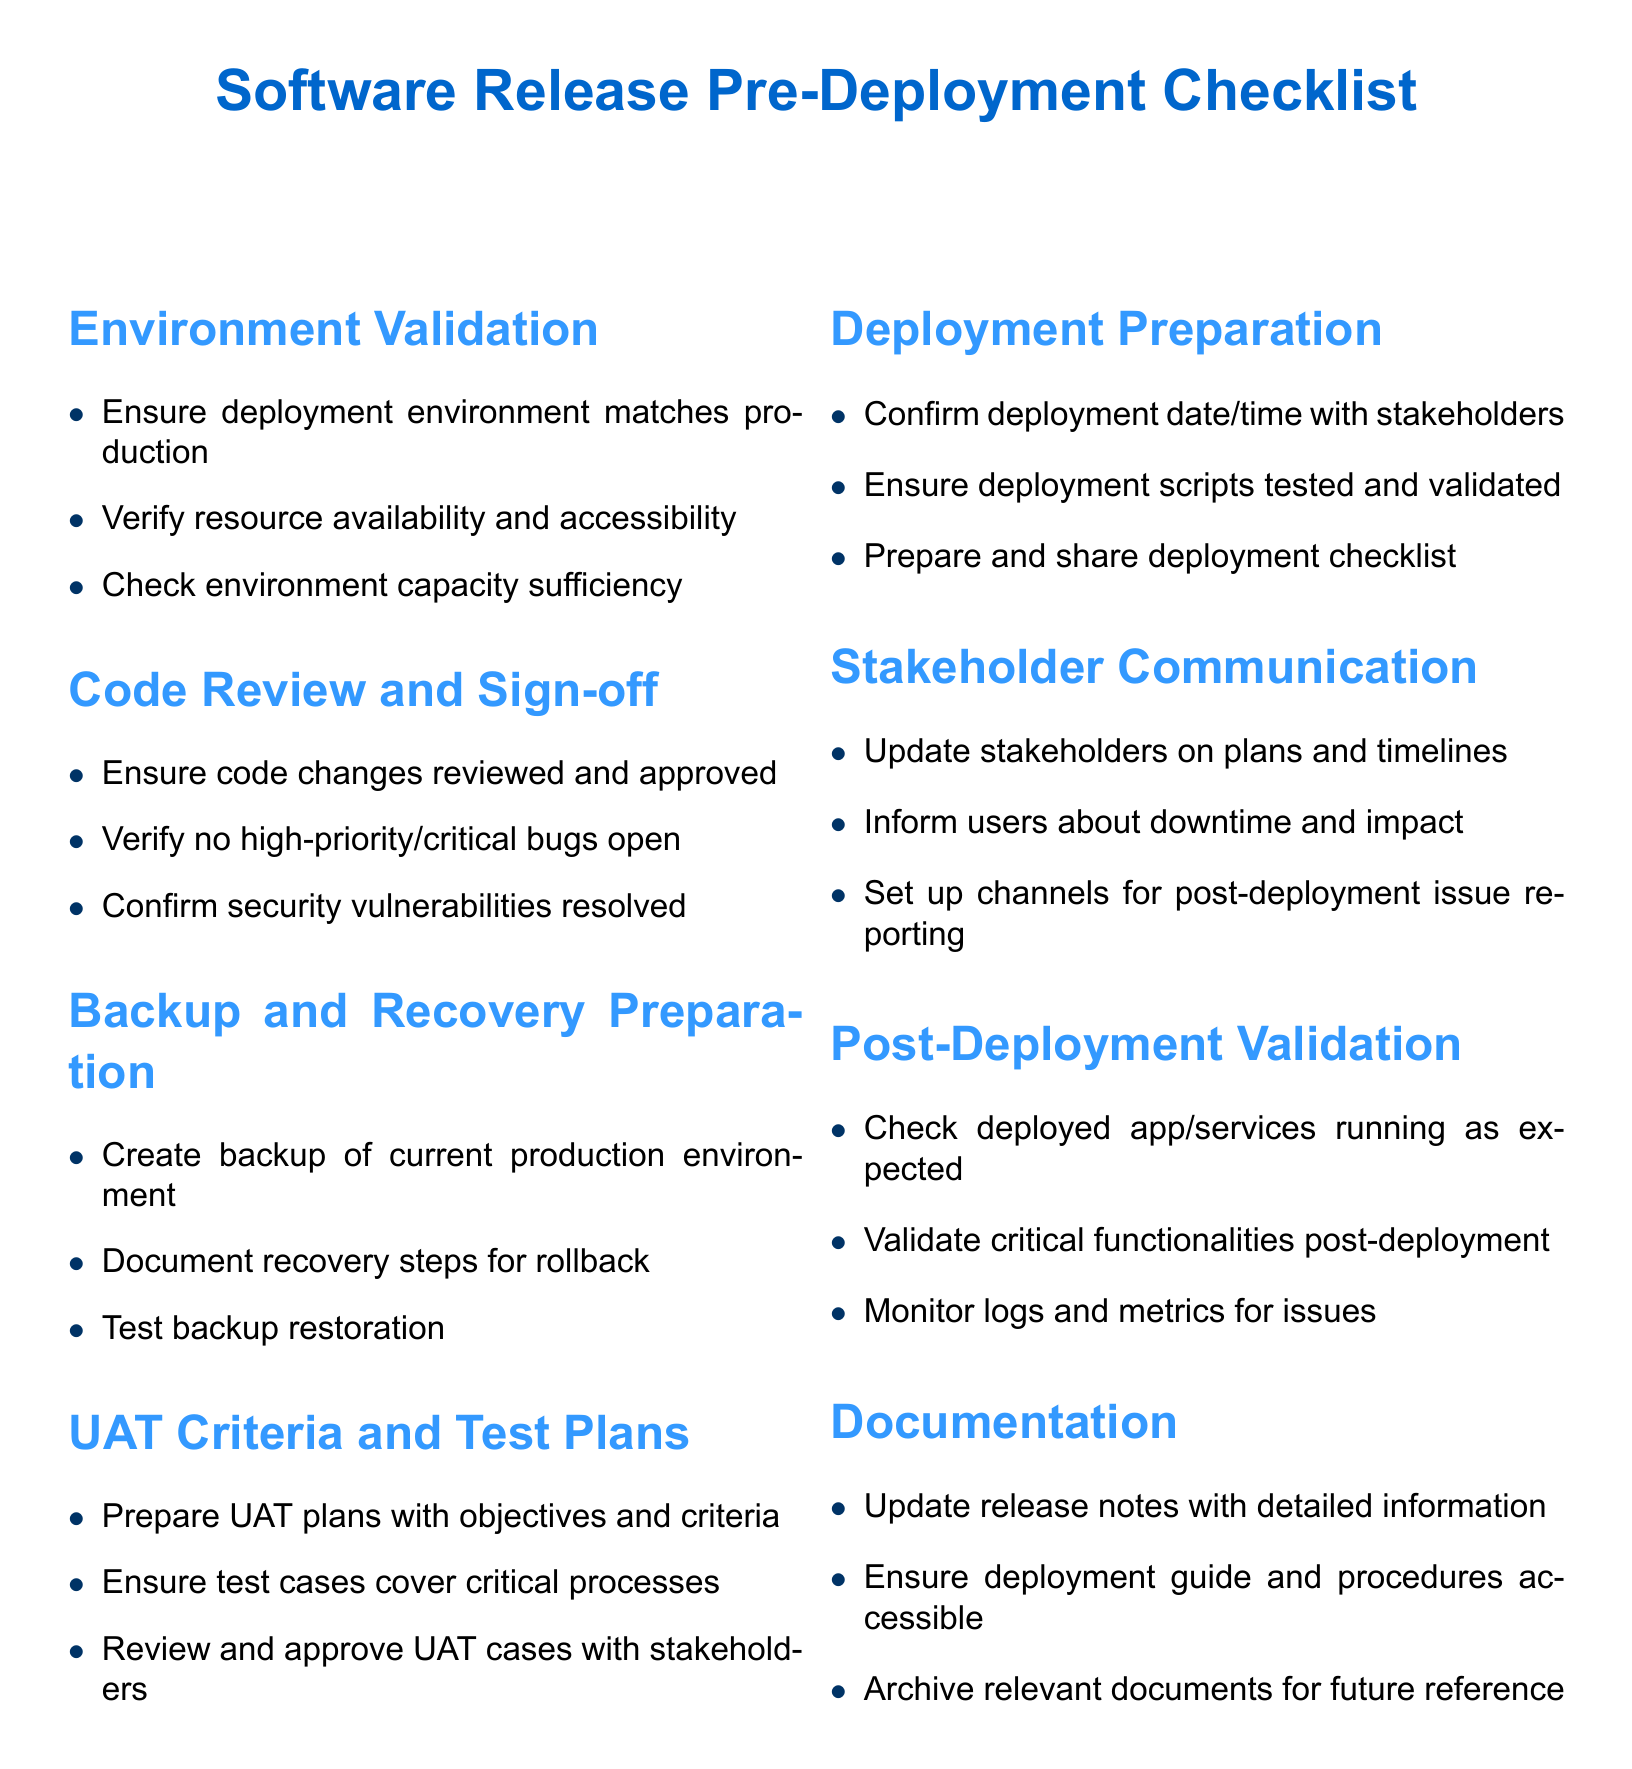What is the first section of the checklist? The checklist begins with the "Environment Validation" section, which covers the validation of the deployment environment.
Answer: Environment Validation How many items are listed under "Code Review and Sign-off"? The "Code Review and Sign-off" section contains three items for validation and sign-off requirements before deployment.
Answer: 3 What does the "Backup and Recovery Preparation" include? This section details creating a backup, documenting recovery steps, and testing backup restoration to ensure recovery readiness.
Answer: Backup creation, recovery steps, restoration testing Who needs to approve the UAT cases? UAT cases must be reviewed and approved by stakeholders to ensure proper validation before going live.
Answer: Stakeholders What is one of the objectives of the "Stakeholder Communication"? Stakeholder communication aims to update stakeholders on plans and timelines, ensuring they are informed about the deployment's impact.
Answer: Update stakeholders How many sections are there in total in the checklist? The checklist consists of eight sections covering various aspects of software deployment preparation.
Answer: 8 What is a critical requirement before "Deployment Preparation"? A critical requirement before deployment preparation is confirming the deployment date and time with stakeholders to ensure alignment.
Answer: Confirm date/time What is included in the "Post-Deployment Validation"? This section includes actions to check that apps/services are running as expected and validate critical functionalities after deployment.
Answer: Check app/services, validate functionalities What is the purpose of updating release notes under "Documentation"? Updating release notes provides detailed information about the release, which is essential for user awareness and future reference.
Answer: Detailed information 